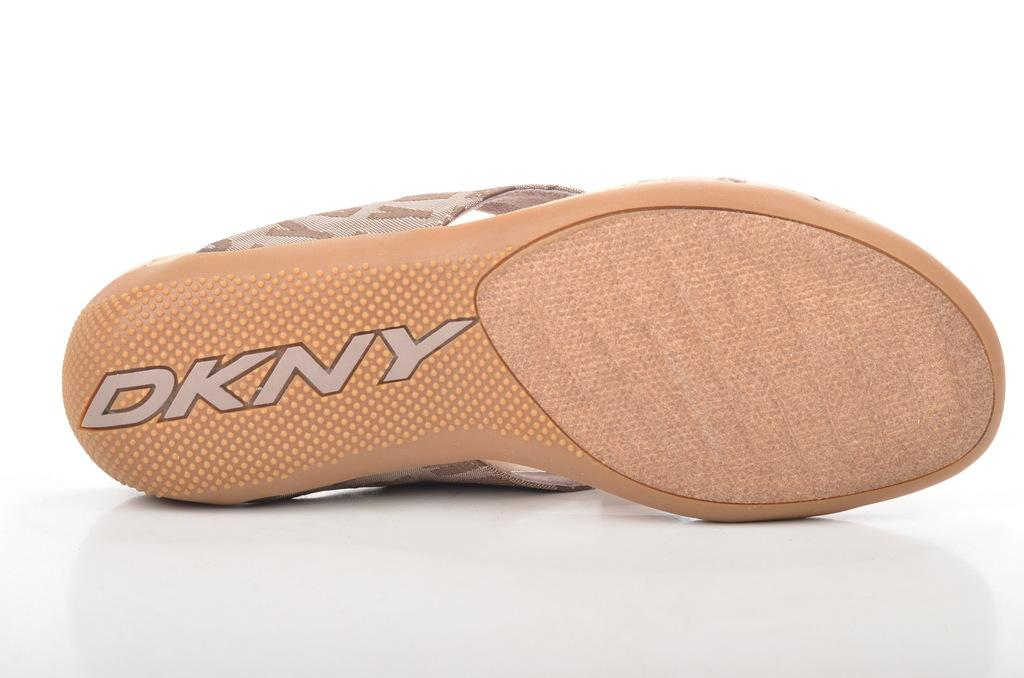What type of item is present in the picture? There is footwear in the picture. What color is the footwear? The footwear is cream in color. Is there any branding on the footwear? Yes, the name "DKNY" is on the footwear. How many holes are visible in the picture? There are no holes visible in the picture; it features footwear with no visible holes. What type of wealth is depicted in the picture? There is no depiction of wealth in the picture; it features footwear with a brand name. 